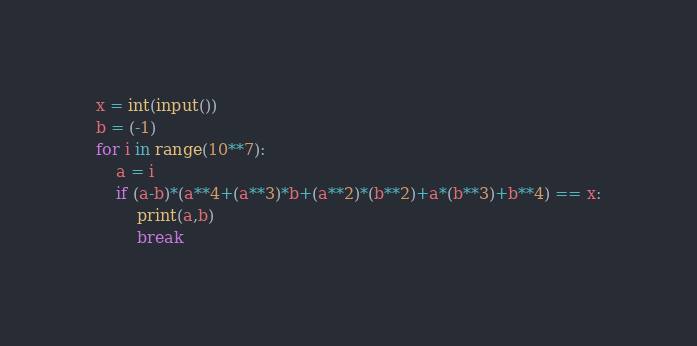Convert code to text. <code><loc_0><loc_0><loc_500><loc_500><_Python_>x = int(input())
b = (-1)
for i in range(10**7):
    a = i
    if (a-b)*(a**4+(a**3)*b+(a**2)*(b**2)+a*(b**3)+b**4) == x:
        print(a,b)
        break</code> 